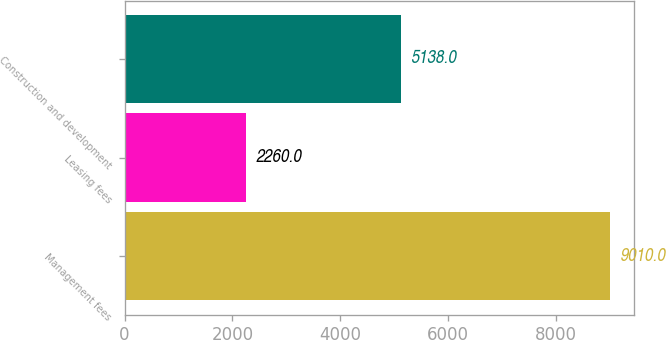<chart> <loc_0><loc_0><loc_500><loc_500><bar_chart><fcel>Management fees<fcel>Leasing fees<fcel>Construction and development<nl><fcel>9010<fcel>2260<fcel>5138<nl></chart> 